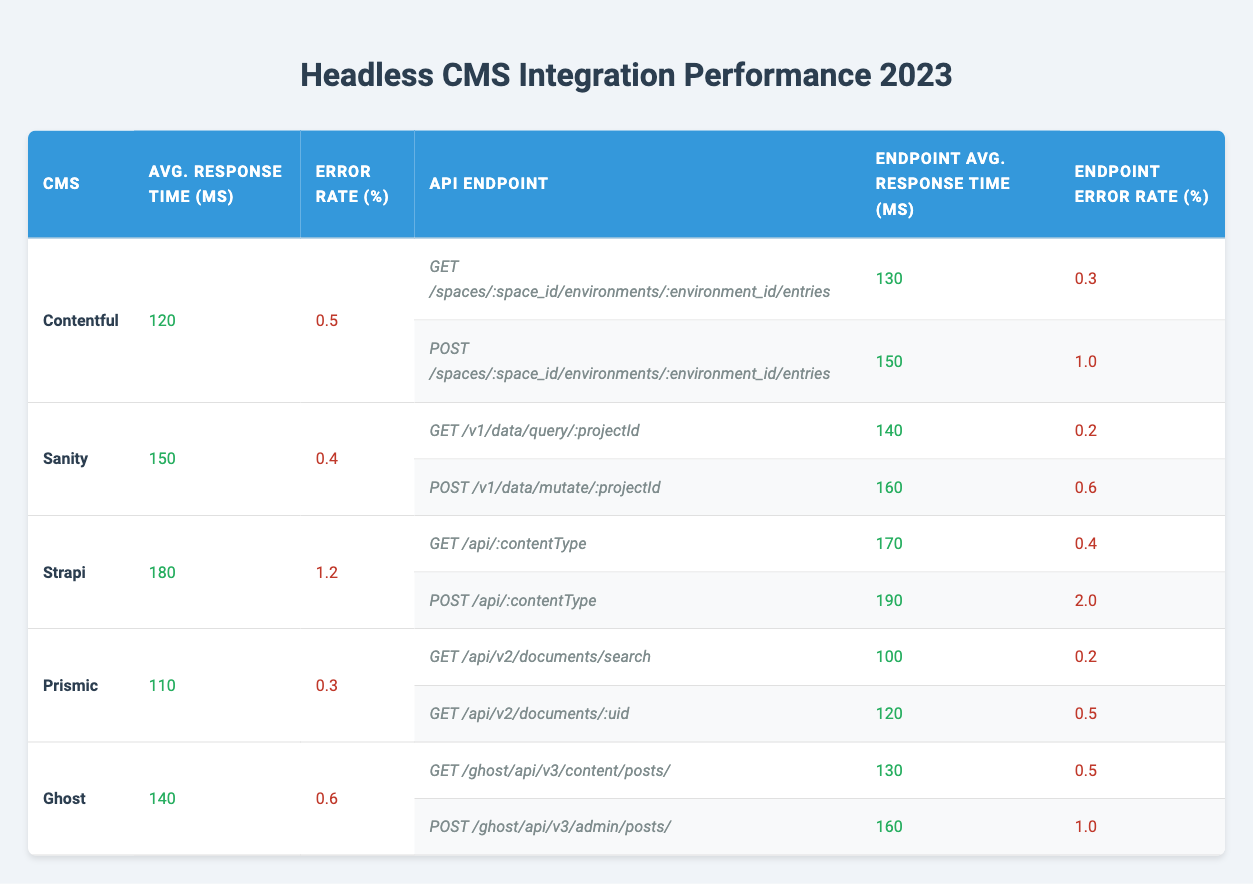What is the average response time for Contentful? From the table, the average response time for Contentful is stated in the second column under its name, which is 120 ms.
Answer: 120 ms What is the error rate for the POST endpoint of Strapi? The error rate for the POST endpoint of Strapi can be found by looking at the corresponding row for that specific endpoint, which shows an error rate of 2.0%.
Answer: 2.0% Which CMS has the lowest average response time? By comparing the average response times listed for each CMS in the second column, Prismic has the lowest average response time at 110 ms.
Answer: Prismic What is the total error rate for all endpoints in Sanity? The endpoints for Sanity are checked: the first endpoint has an error rate of 0.2% and the second has 0.6%. The total error rate is the sum of these two values: 0.2 + 0.6 = 0.8%.
Answer: 0.8% Is the average response time for Ghost lower than that for Strapi? The average response time for Ghost is 140 ms and for Strapi, it is 180 ms. Since 140 is less than 180, the average response time for Ghost is indeed lower than that for Strapi.
Answer: Yes What is the highest error rate among all CMS integrations mentioned? By examining the error rates across all CMS integrations, Strapi has the highest error rate at 1.2%.
Answer: 1.2% If I combine the average response times of the GET endpoints for Contentful and Prismic, what will be the total? The average response time for the GET endpoint of Contentful is 130 ms and for Prismic is 100 ms. Adding these together gives: 130 + 100 = 230 ms.
Answer: 230 ms Which CMS has a GET endpoint with the fastest response time? The fastest response time for a GET endpoint is for Prismic's endpoint, which is 100 ms.
Answer: Prismic What is the average response time for all POST endpoints combined? To find the average response time for all POST endpoints, we sum the individual response times: 150 (Contentful) + 160 (Sanity) + 190 (Strapi) + 160 (Ghost) = 660 ms. There are 4 POST endpoints, so the average is 660 / 4 = 165 ms.
Answer: 165 ms 